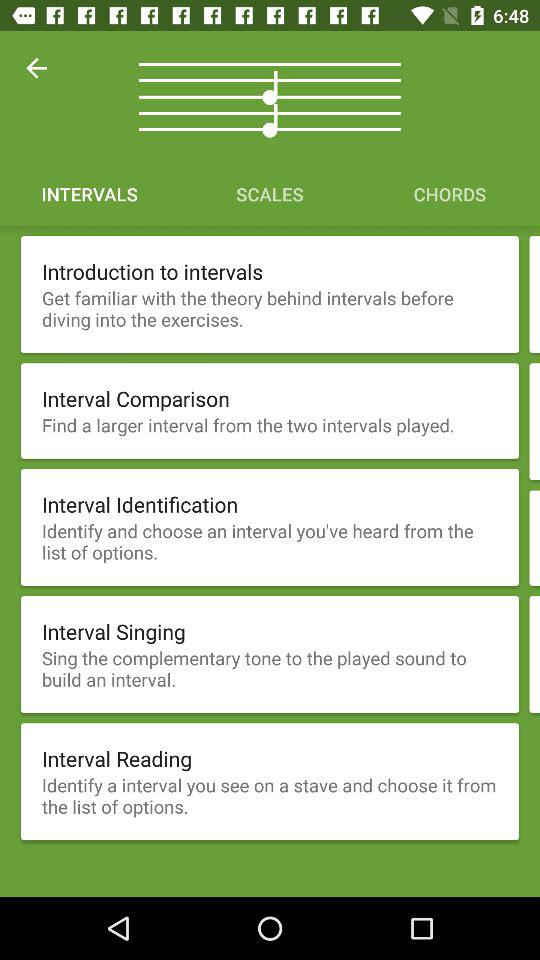How many exercises are available for intervals?
Answer the question using a single word or phrase. 5 